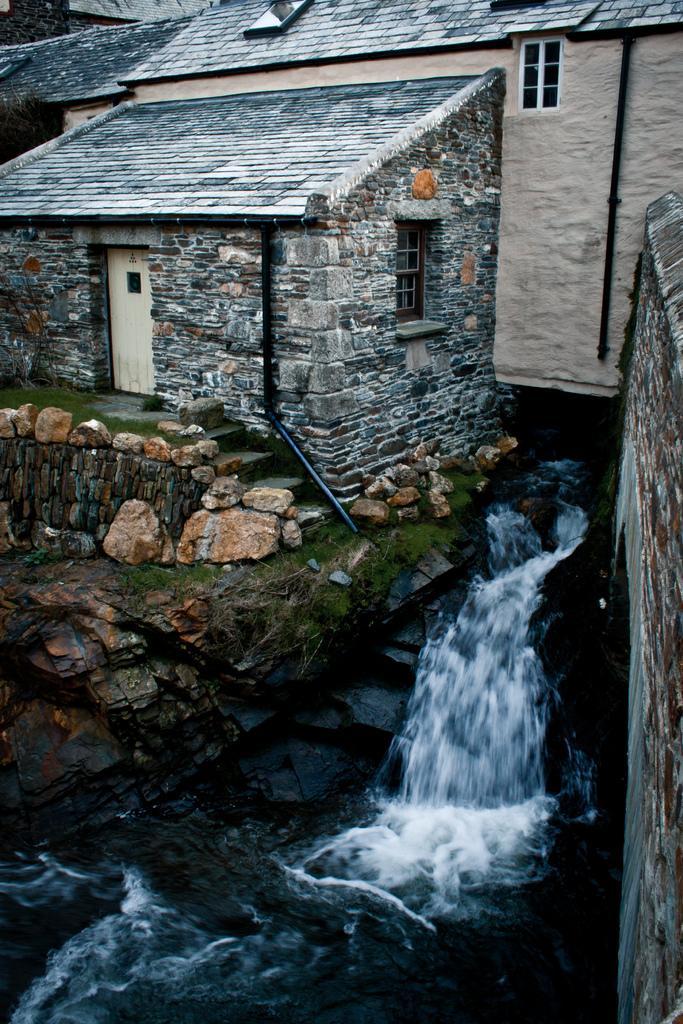In one or two sentences, can you explain what this image depicts? In this image I can see building, water, few stones and grass. 